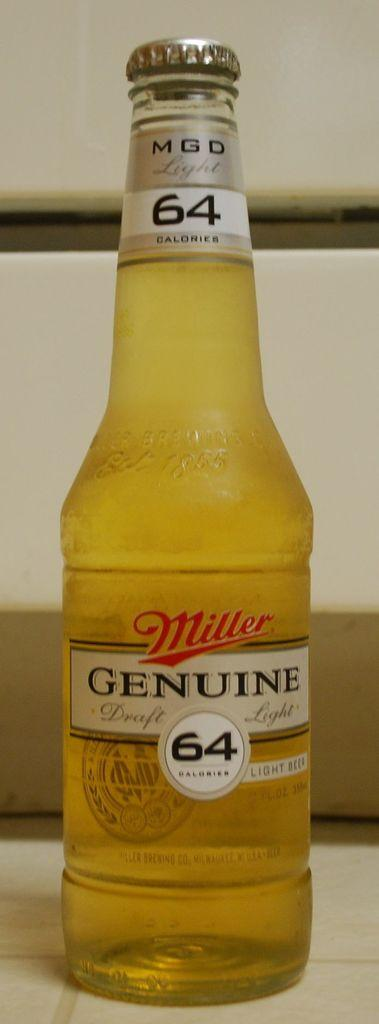<image>
Summarize the visual content of the image. a bottle of Miller Genuine 64 calories light beer 